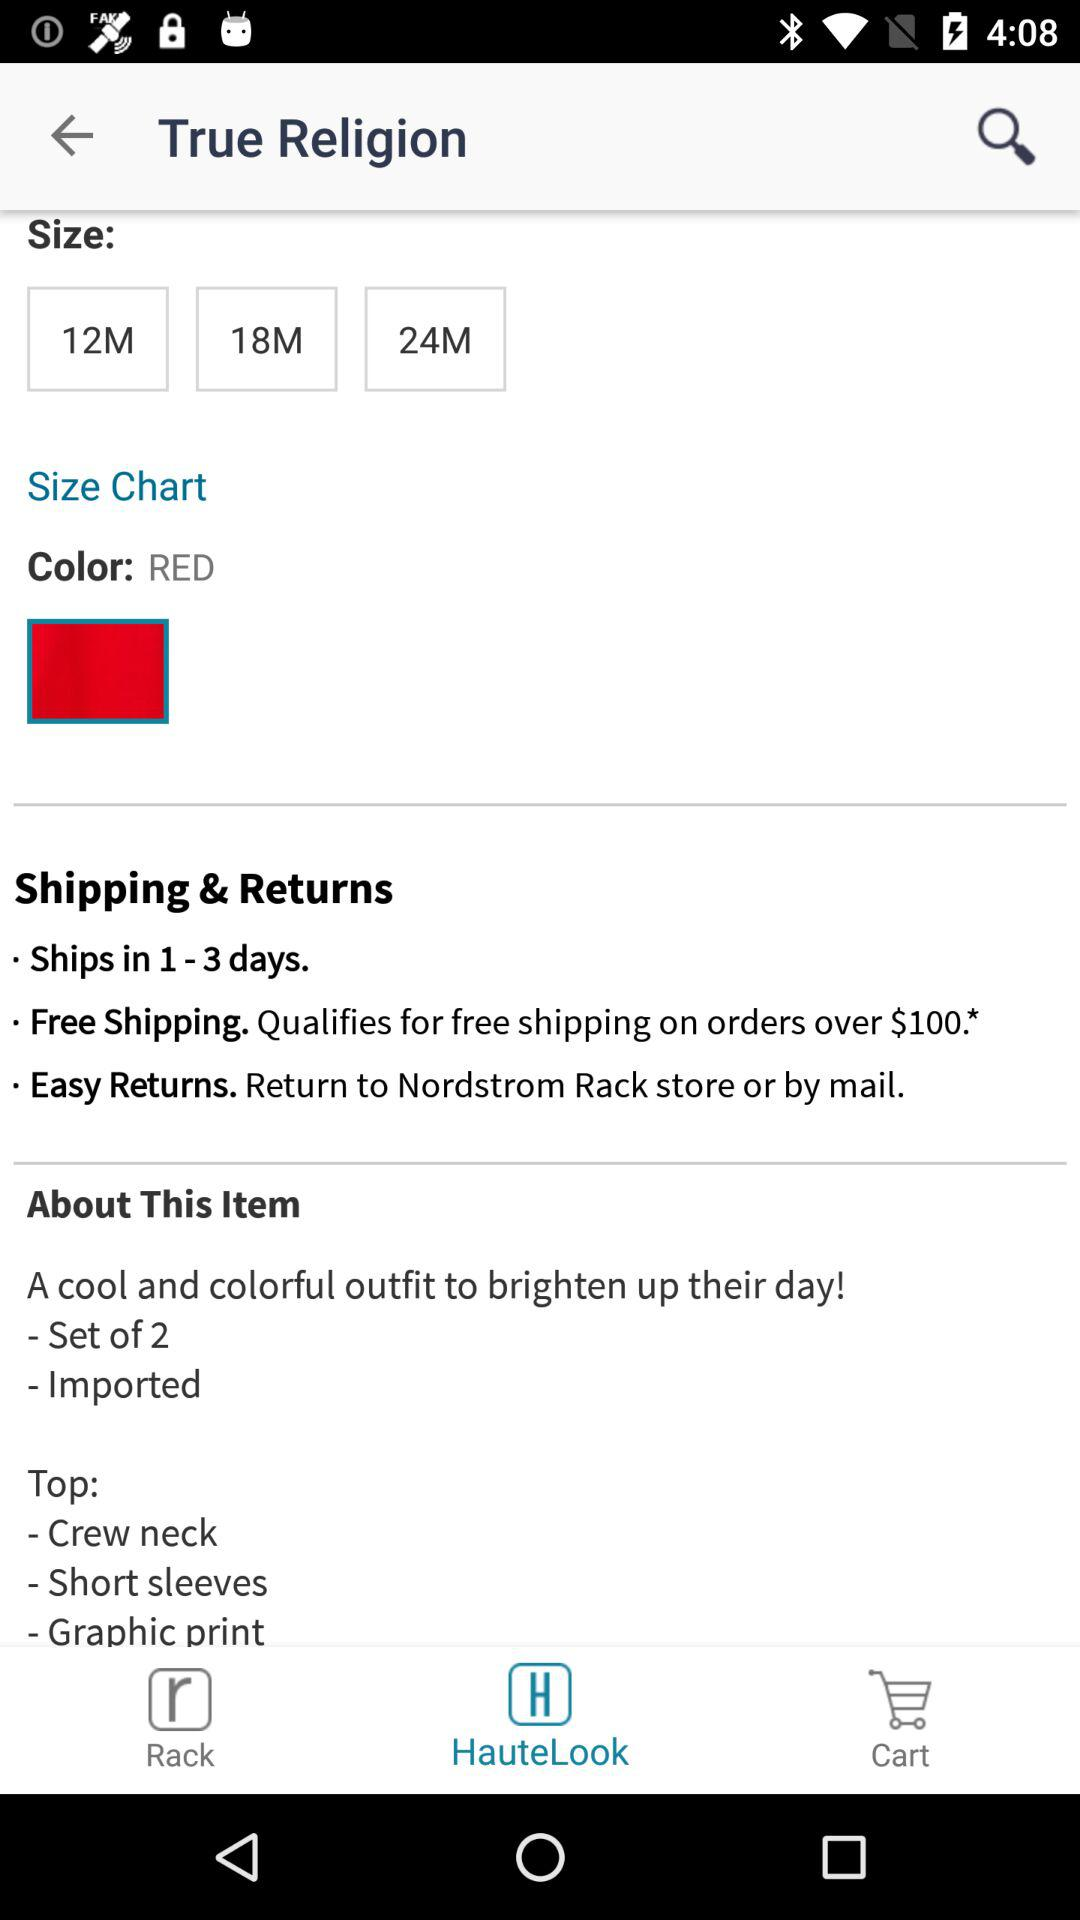Which tab is open? The open tab is "HauteLook". 